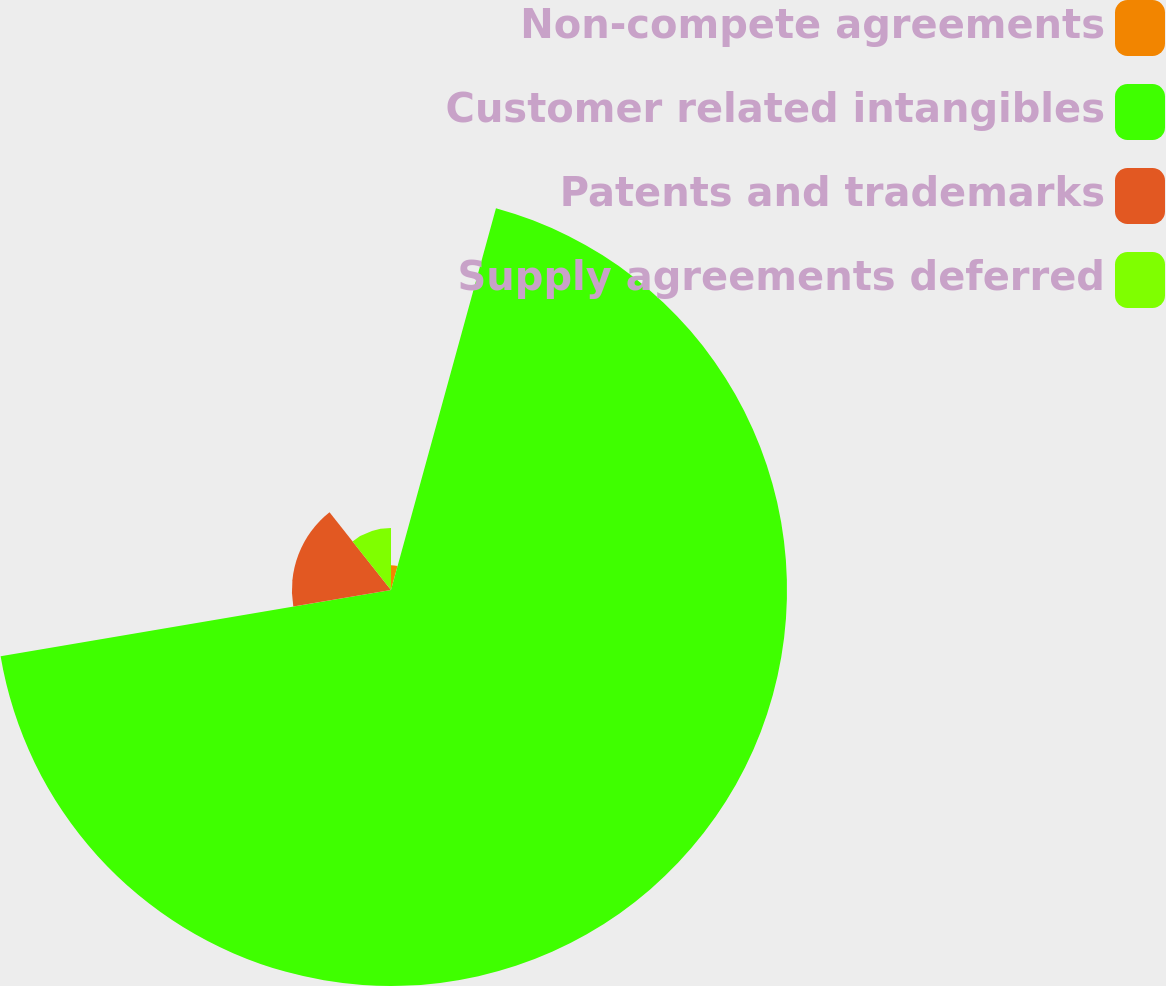Convert chart. <chart><loc_0><loc_0><loc_500><loc_500><pie_chart><fcel>Non-compete agreements<fcel>Customer related intangibles<fcel>Patents and trademarks<fcel>Supply agreements deferred<nl><fcel>4.27%<fcel>68.05%<fcel>17.03%<fcel>10.65%<nl></chart> 